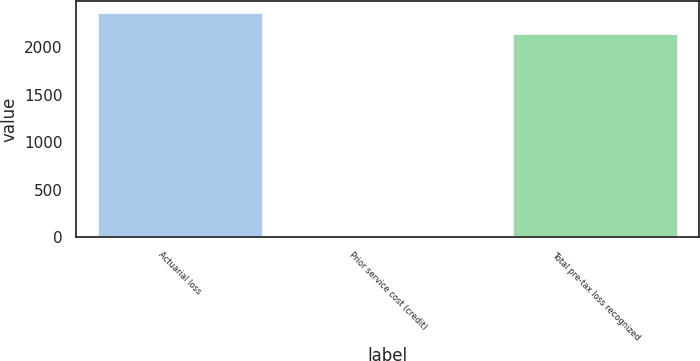Convert chart to OTSL. <chart><loc_0><loc_0><loc_500><loc_500><bar_chart><fcel>Actuarial loss<fcel>Prior service cost (credit)<fcel>Total pre-tax loss recognized<nl><fcel>2372.7<fcel>1<fcel>2148<nl></chart> 